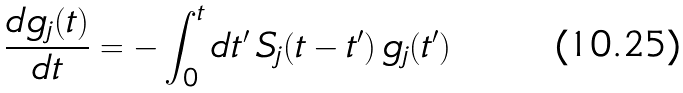Convert formula to latex. <formula><loc_0><loc_0><loc_500><loc_500>\frac { d g _ { j } ( t ) } { d t } = - \int _ { 0 } ^ { t } d t ^ { \prime } \, S _ { j } ( t - t ^ { \prime } ) \, g _ { j } ( t ^ { \prime } )</formula> 